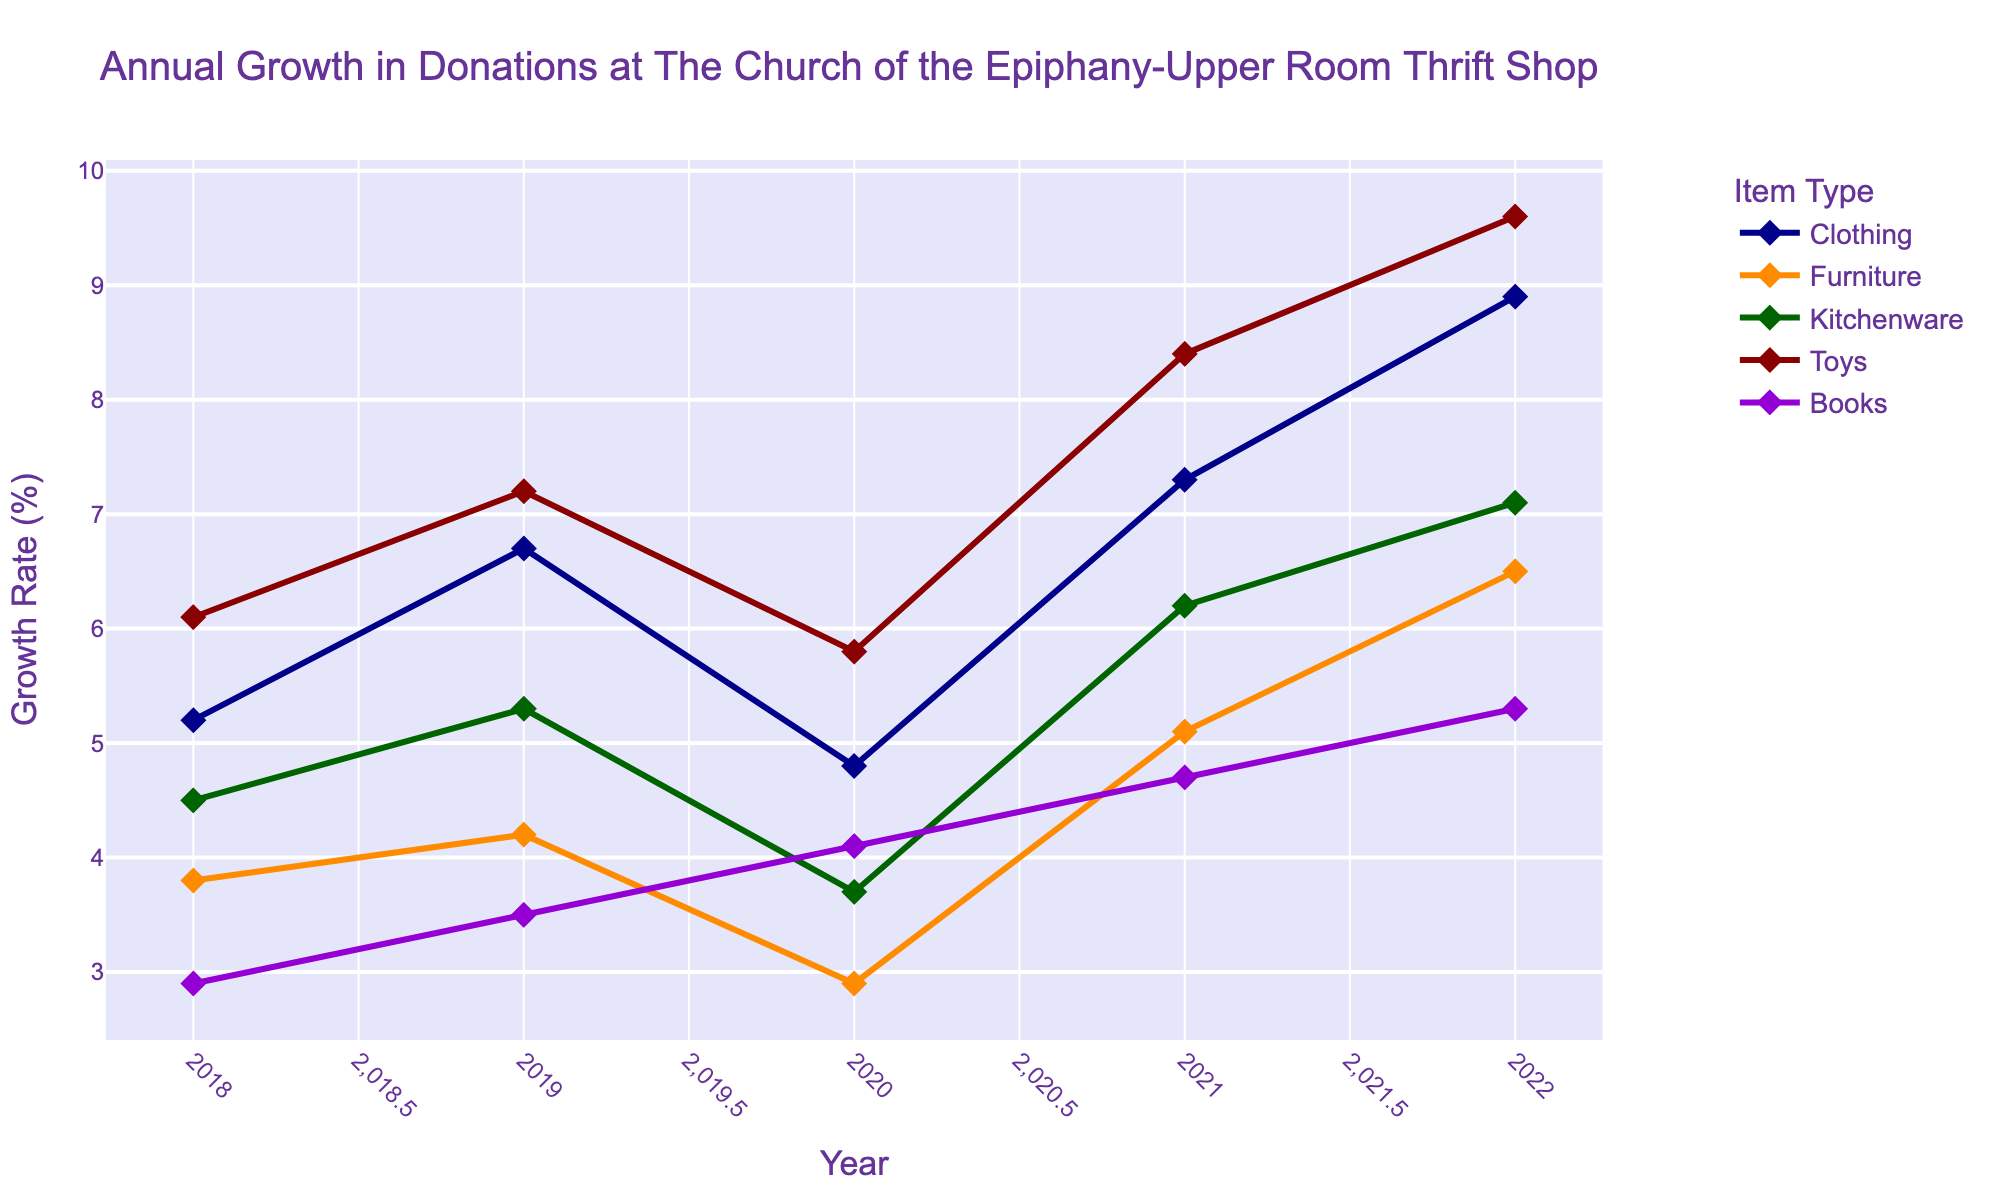What's the average growth rate for Clothing from 2018 to 2022? To find the average, sum the annual growth rates for Clothing (5.2, 6.7, 4.8, 7.3, 8.9) and divide by the number of years. The sum is 32.9 and the average is 32.9/5 = 6.58
Answer: 6.58 Which item type had the highest growth rate in 2022? By checking the data for 2022, we see the growth rates are: Clothing (8.9), Furniture (6.5), Kitchenware (7.1), Toys (9.6), Books (5.3). Toys had the highest growth rate with 9.6%
Answer: Toys Did any item type experience a decline in growth in 2020 compared to 2019? Compare the growth rates from 2019 to 2020 for each item: Clothing (6.7 to 4.8), Furniture (4.2 to 2.9), Kitchenware (5.3 to 3.7), Toys (7.2 to 5.8), Books (3.5 to 4.1). Each item listed has a decline except Books, which increased.
Answer: Yes How did the growth rate of Books change from 2020 to 2021? The growth rate for Books in 2020 was 4.1 and in 2021 it was 4.7. Subtract the 2020 rate from the 2021 rate: 4.7 - 4.1 = 0.6.
Answer: Increased by 0.6 Which year had the highest overall growth rate for Clothing? By reviewing the annual growth rates for Clothing: 5.2 (2018), 6.7 (2019), 4.8 (2020), 7.3 (2021), 8.9 (2022), 2022 has the highest growth rate at 8.9%.
Answer: 2022 Compare the growth rates of Furniture and Kitchenware in 2019; which one was greater? The growth rate for Furniture in 2019 was 4.2, and for Kitchenware, it was 5.3. Since 5.3 is greater than 4.2, Kitchenware had a higher growth rate.
Answer: Kitchenware What was the combined growth rate for Toys in 2018 and 2020? The growth rate for Toys in 2018 was 6.1 and in 2020 it was 5.8. Add these two rates: 6.1 + 5.8 = 11.9
Answer: 11.9 Which item type showed the most consistent growth rate from 2018 to 2022? Consistency can be evaluated by looking for minimal fluctuations in the annual growth rates. Books have growth rates of 2.9, 3.5, 4.1, 4.7, and 5.3, showing a steady rise, suggesting it is the most consistent.
Answer: Books What is the percentage difference between the growth rates of Furniture and Toys in 2022? Growth rates for 2022: Furniture is 6.5%, Toys is 9.6%. Calculate the difference: 9.6 - 6.5 = 3.1%.
Answer: 3.1 What is the sum of the growth rates for Kitchenware from 2018 to 2021? Add the growth rates for Kitchenware for each year from 2018 to 2021: 4.5 + 5.3 + 3.7 + 6.2 = 19.7.
Answer: 19.7 